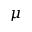Convert formula to latex. <formula><loc_0><loc_0><loc_500><loc_500>\mu</formula> 